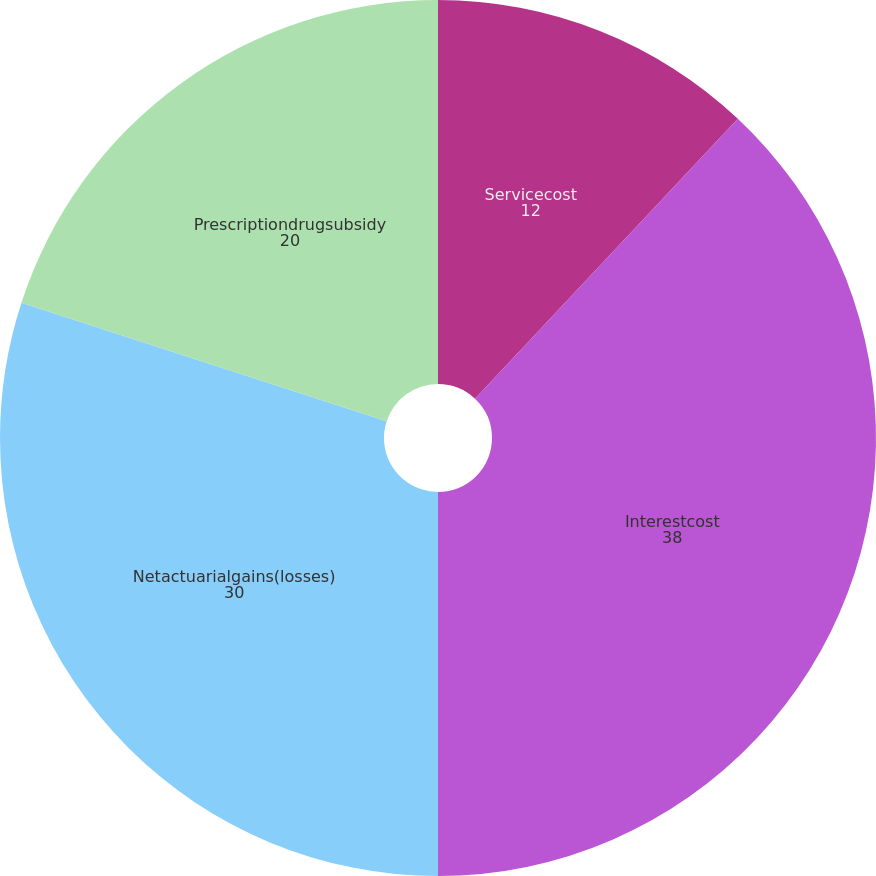<chart> <loc_0><loc_0><loc_500><loc_500><pie_chart><fcel>Servicecost<fcel>Interestcost<fcel>Netactuarialgains(losses)<fcel>Prescriptiondrugsubsidy<nl><fcel>12.0%<fcel>38.0%<fcel>30.0%<fcel>20.0%<nl></chart> 